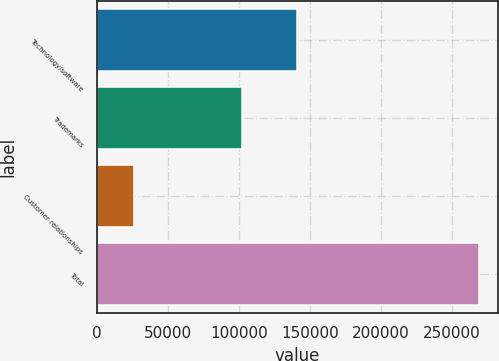Convert chart. <chart><loc_0><loc_0><loc_500><loc_500><bar_chart><fcel>Technology/software<fcel>Trademarks<fcel>Customer relationships<fcel>Total<nl><fcel>140800<fcel>102220<fcel>25880<fcel>268950<nl></chart> 